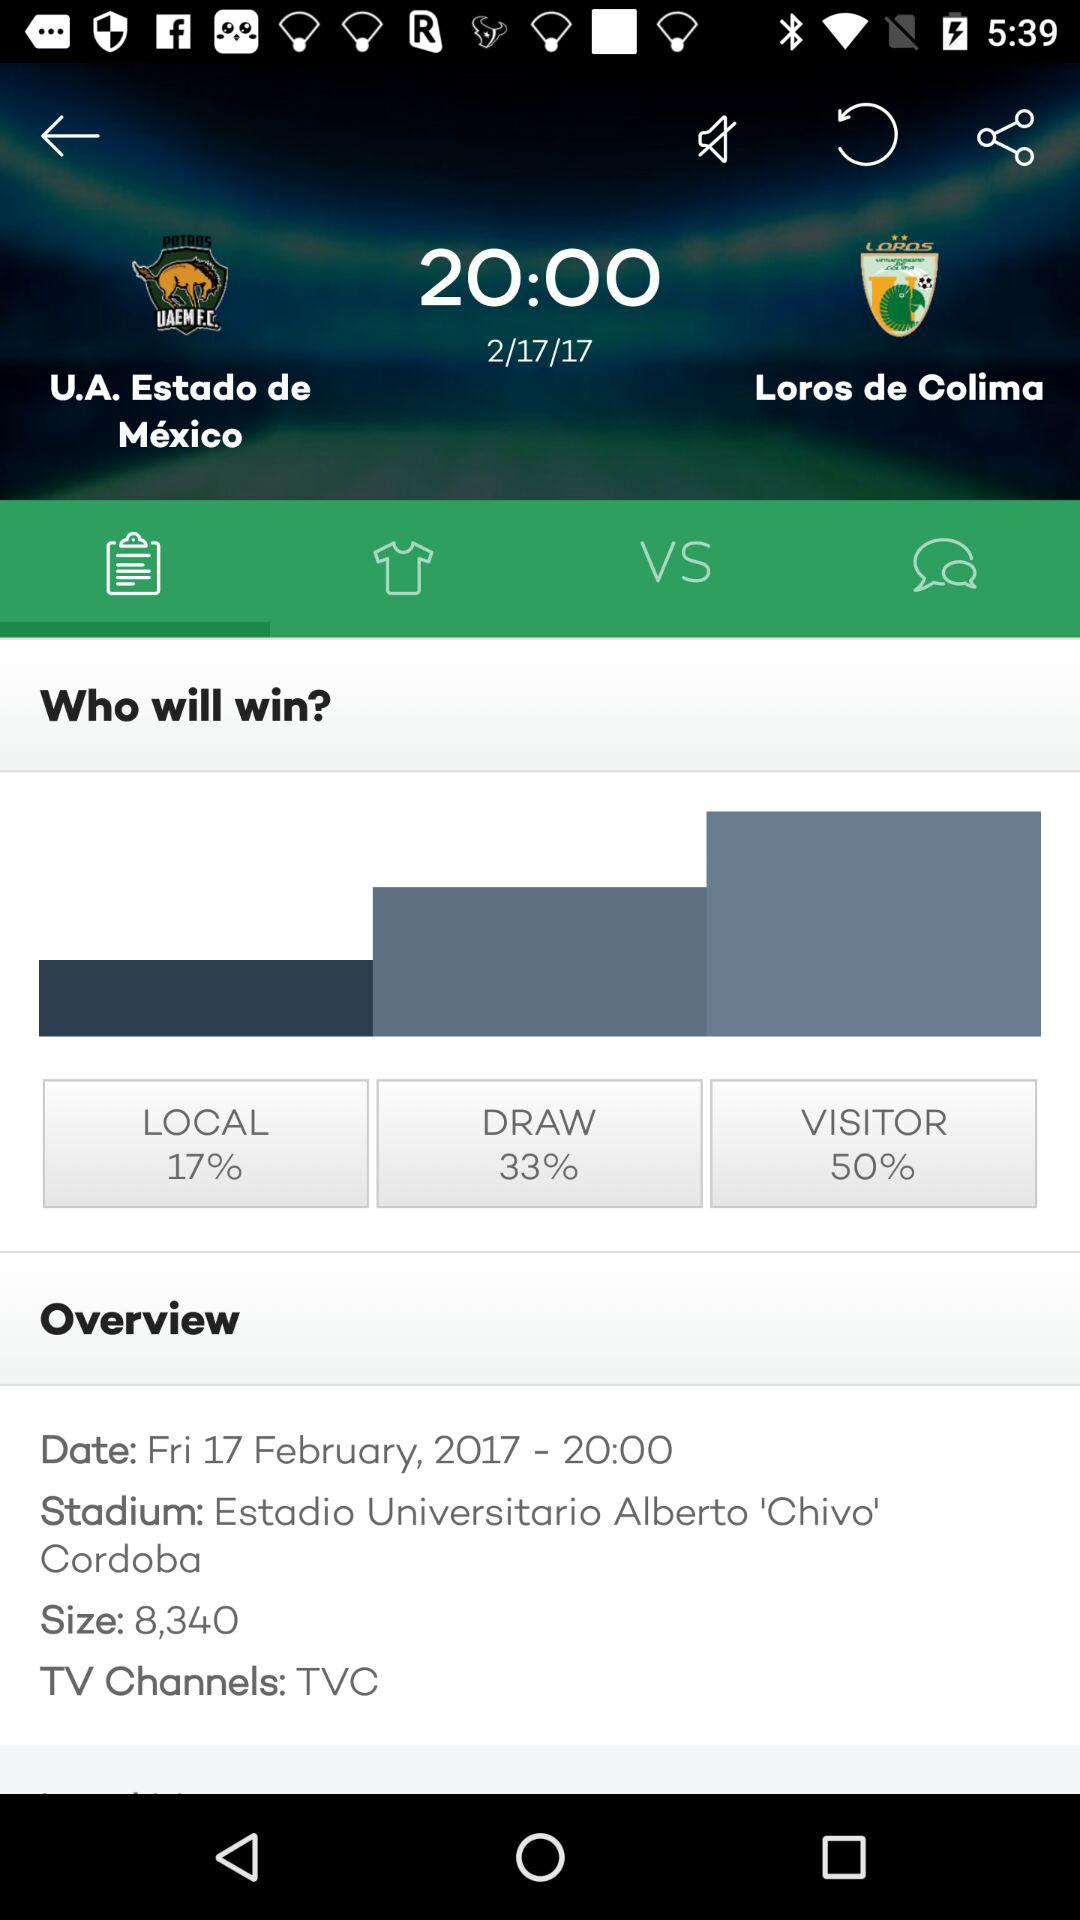When is the match? The match is on Friday, February 17, 2017 at 8 p.m. 